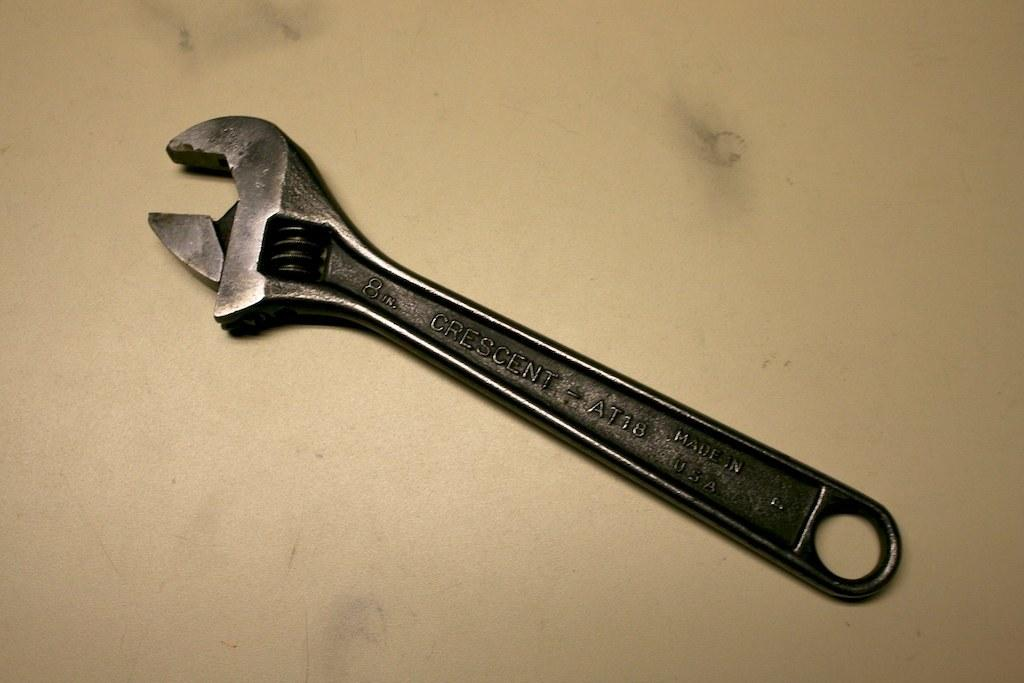What tool is visible in the image? There is a wrench in the image. Where is the wrench located? The wrench is placed on a table. What color is the cloud in the image? There is no cloud present in the image. Does the existence of the wrench in the image prove the existence of extraterrestrial life? The existence of the wrench in the image does not prove the existence of extraterrestrial life, as it is a common tool used by humans. 